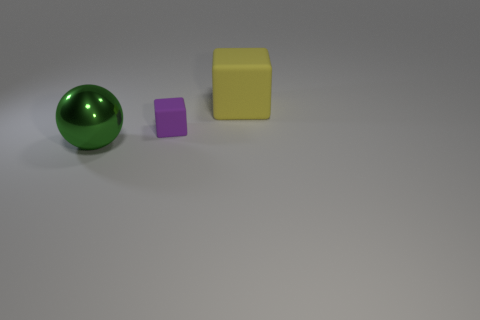Is there anything else that has the same material as the large sphere?
Give a very brief answer. No. There is a matte object that is the same size as the ball; what is its shape?
Make the answer very short. Cube. How many things are tiny purple rubber objects or matte things that are in front of the yellow block?
Your answer should be compact. 1. How many things are behind the large shiny thing?
Give a very brief answer. 2. There is a big block that is the same material as the small purple block; what color is it?
Give a very brief answer. Yellow. What number of metal things are either big brown balls or green balls?
Your answer should be compact. 1. Is the material of the tiny purple thing the same as the large block?
Provide a succinct answer. Yes. What shape is the object that is in front of the small purple block?
Your response must be concise. Sphere. Is there a purple rubber block that is on the right side of the matte cube right of the purple matte block?
Your response must be concise. No. Is there a green thing that has the same size as the yellow matte object?
Your response must be concise. Yes. 